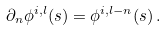<formula> <loc_0><loc_0><loc_500><loc_500>\partial _ { n } \phi ^ { i , l } ( s ) = \phi ^ { i , l - n } ( s ) \, .</formula> 